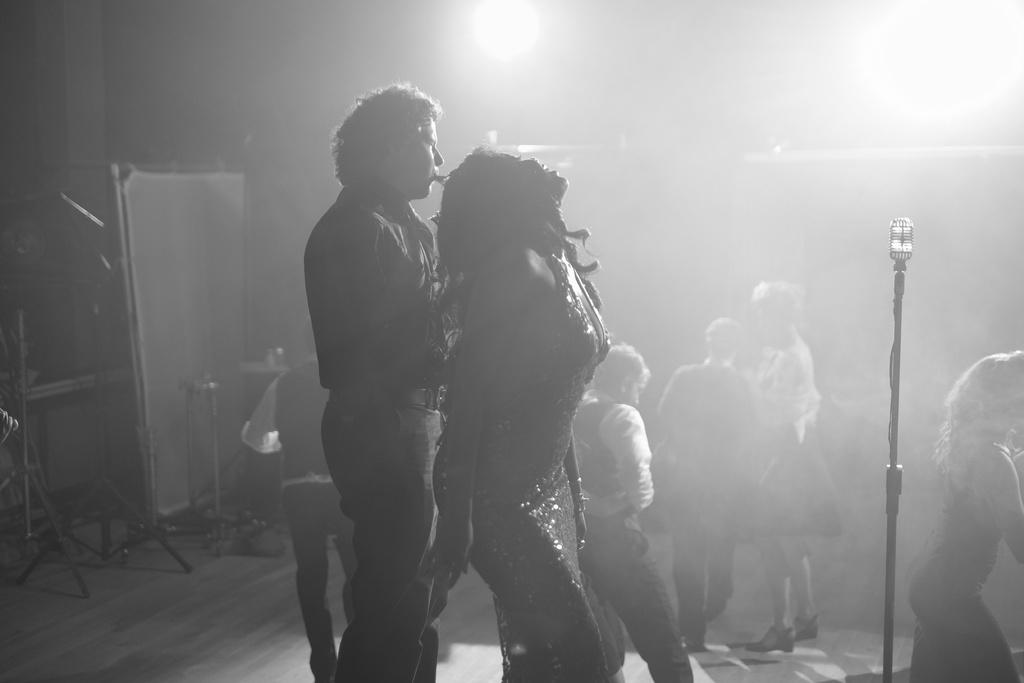Who or what can be seen in the image? There are people in the image. What is the surface beneath the people in the image? The ground is visible in the image. What equipment is present in the image? There is a microphone with a stand in the image. What type of structure is present in the image? There are poles in the image. Can you describe a specific pole in the image? There is a pole with cloth in the image. What is attached to the wall in the image? There is a wall with lights in the image. What type of wax can be seen melting on the giraffe in the image? There is no giraffe or wax present in the image. 